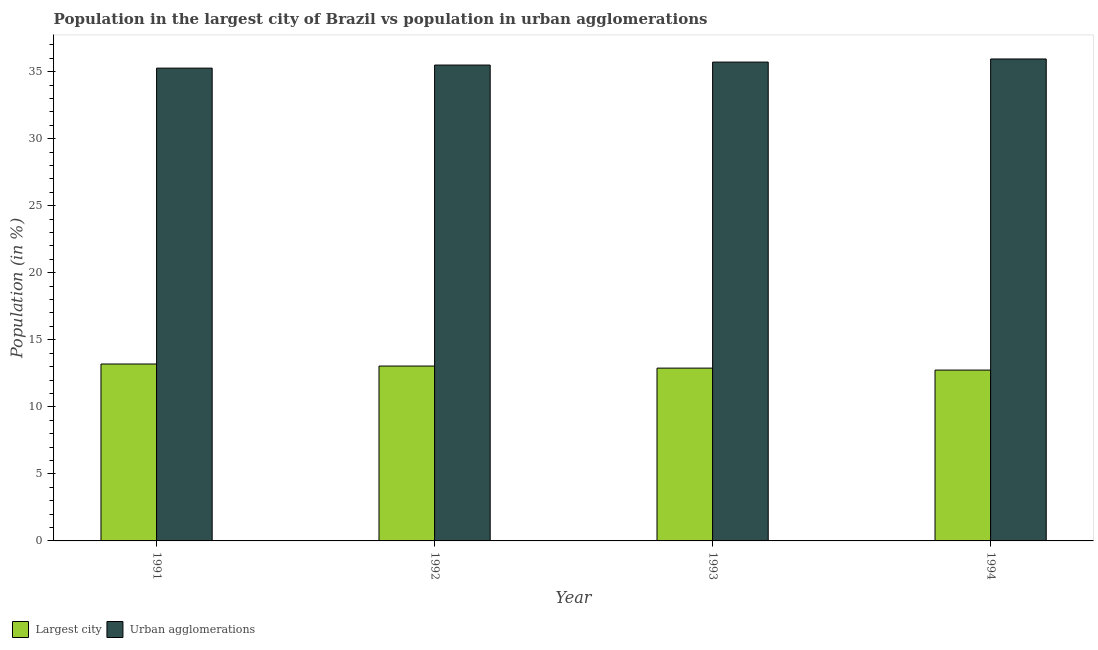How many groups of bars are there?
Your answer should be compact. 4. What is the population in urban agglomerations in 1991?
Keep it short and to the point. 35.26. Across all years, what is the maximum population in urban agglomerations?
Your answer should be compact. 35.94. Across all years, what is the minimum population in the largest city?
Provide a short and direct response. 12.74. In which year was the population in the largest city minimum?
Your answer should be very brief. 1994. What is the total population in urban agglomerations in the graph?
Give a very brief answer. 142.4. What is the difference between the population in the largest city in 1991 and that in 1992?
Offer a very short reply. 0.15. What is the difference between the population in urban agglomerations in 1992 and the population in the largest city in 1994?
Provide a succinct answer. -0.45. What is the average population in urban agglomerations per year?
Keep it short and to the point. 35.6. In the year 1991, what is the difference between the population in urban agglomerations and population in the largest city?
Provide a short and direct response. 0. In how many years, is the population in the largest city greater than 8 %?
Your response must be concise. 4. What is the ratio of the population in urban agglomerations in 1991 to that in 1992?
Your response must be concise. 0.99. Is the difference between the population in the largest city in 1991 and 1994 greater than the difference between the population in urban agglomerations in 1991 and 1994?
Provide a succinct answer. No. What is the difference between the highest and the second highest population in urban agglomerations?
Offer a terse response. 0.23. What is the difference between the highest and the lowest population in the largest city?
Your response must be concise. 0.45. What does the 1st bar from the left in 1994 represents?
Make the answer very short. Largest city. What does the 1st bar from the right in 1991 represents?
Offer a terse response. Urban agglomerations. How many years are there in the graph?
Your answer should be compact. 4. What is the difference between two consecutive major ticks on the Y-axis?
Offer a very short reply. 5. Does the graph contain any zero values?
Give a very brief answer. No. Does the graph contain grids?
Your answer should be compact. No. How are the legend labels stacked?
Your answer should be compact. Horizontal. What is the title of the graph?
Your answer should be very brief. Population in the largest city of Brazil vs population in urban agglomerations. Does "Arms imports" appear as one of the legend labels in the graph?
Give a very brief answer. No. What is the label or title of the X-axis?
Keep it short and to the point. Year. What is the label or title of the Y-axis?
Ensure brevity in your answer.  Population (in %). What is the Population (in %) of Largest city in 1991?
Provide a succinct answer. 13.19. What is the Population (in %) in Urban agglomerations in 1991?
Your answer should be very brief. 35.26. What is the Population (in %) in Largest city in 1992?
Your answer should be compact. 13.04. What is the Population (in %) in Urban agglomerations in 1992?
Offer a terse response. 35.49. What is the Population (in %) of Largest city in 1993?
Your answer should be compact. 12.89. What is the Population (in %) of Urban agglomerations in 1993?
Provide a succinct answer. 35.71. What is the Population (in %) in Largest city in 1994?
Make the answer very short. 12.74. What is the Population (in %) of Urban agglomerations in 1994?
Provide a short and direct response. 35.94. Across all years, what is the maximum Population (in %) of Largest city?
Ensure brevity in your answer.  13.19. Across all years, what is the maximum Population (in %) in Urban agglomerations?
Offer a terse response. 35.94. Across all years, what is the minimum Population (in %) of Largest city?
Your answer should be very brief. 12.74. Across all years, what is the minimum Population (in %) in Urban agglomerations?
Make the answer very short. 35.26. What is the total Population (in %) of Largest city in the graph?
Offer a terse response. 51.86. What is the total Population (in %) in Urban agglomerations in the graph?
Offer a very short reply. 142.4. What is the difference between the Population (in %) in Largest city in 1991 and that in 1992?
Keep it short and to the point. 0.15. What is the difference between the Population (in %) of Urban agglomerations in 1991 and that in 1992?
Provide a short and direct response. -0.23. What is the difference between the Population (in %) of Largest city in 1991 and that in 1993?
Your response must be concise. 0.31. What is the difference between the Population (in %) of Urban agglomerations in 1991 and that in 1993?
Keep it short and to the point. -0.45. What is the difference between the Population (in %) of Largest city in 1991 and that in 1994?
Keep it short and to the point. 0.45. What is the difference between the Population (in %) of Urban agglomerations in 1991 and that in 1994?
Provide a succinct answer. -0.68. What is the difference between the Population (in %) of Largest city in 1992 and that in 1993?
Give a very brief answer. 0.15. What is the difference between the Population (in %) in Urban agglomerations in 1992 and that in 1993?
Give a very brief answer. -0.22. What is the difference between the Population (in %) of Largest city in 1992 and that in 1994?
Your answer should be compact. 0.3. What is the difference between the Population (in %) in Urban agglomerations in 1992 and that in 1994?
Your response must be concise. -0.45. What is the difference between the Population (in %) of Largest city in 1993 and that in 1994?
Ensure brevity in your answer.  0.15. What is the difference between the Population (in %) of Urban agglomerations in 1993 and that in 1994?
Keep it short and to the point. -0.23. What is the difference between the Population (in %) in Largest city in 1991 and the Population (in %) in Urban agglomerations in 1992?
Your response must be concise. -22.3. What is the difference between the Population (in %) of Largest city in 1991 and the Population (in %) of Urban agglomerations in 1993?
Ensure brevity in your answer.  -22.52. What is the difference between the Population (in %) of Largest city in 1991 and the Population (in %) of Urban agglomerations in 1994?
Make the answer very short. -22.75. What is the difference between the Population (in %) of Largest city in 1992 and the Population (in %) of Urban agglomerations in 1993?
Offer a terse response. -22.67. What is the difference between the Population (in %) of Largest city in 1992 and the Population (in %) of Urban agglomerations in 1994?
Keep it short and to the point. -22.9. What is the difference between the Population (in %) in Largest city in 1993 and the Population (in %) in Urban agglomerations in 1994?
Your answer should be compact. -23.06. What is the average Population (in %) in Largest city per year?
Ensure brevity in your answer.  12.97. What is the average Population (in %) of Urban agglomerations per year?
Your answer should be compact. 35.6. In the year 1991, what is the difference between the Population (in %) of Largest city and Population (in %) of Urban agglomerations?
Your answer should be compact. -22.07. In the year 1992, what is the difference between the Population (in %) in Largest city and Population (in %) in Urban agglomerations?
Make the answer very short. -22.45. In the year 1993, what is the difference between the Population (in %) of Largest city and Population (in %) of Urban agglomerations?
Make the answer very short. -22.82. In the year 1994, what is the difference between the Population (in %) of Largest city and Population (in %) of Urban agglomerations?
Provide a short and direct response. -23.2. What is the ratio of the Population (in %) in Largest city in 1991 to that in 1992?
Offer a terse response. 1.01. What is the ratio of the Population (in %) of Largest city in 1991 to that in 1993?
Ensure brevity in your answer.  1.02. What is the ratio of the Population (in %) in Urban agglomerations in 1991 to that in 1993?
Give a very brief answer. 0.99. What is the ratio of the Population (in %) of Largest city in 1991 to that in 1994?
Give a very brief answer. 1.04. What is the ratio of the Population (in %) of Urban agglomerations in 1992 to that in 1993?
Provide a succinct answer. 0.99. What is the ratio of the Population (in %) of Largest city in 1992 to that in 1994?
Ensure brevity in your answer.  1.02. What is the ratio of the Population (in %) in Urban agglomerations in 1992 to that in 1994?
Your response must be concise. 0.99. What is the ratio of the Population (in %) of Largest city in 1993 to that in 1994?
Offer a very short reply. 1.01. What is the difference between the highest and the second highest Population (in %) of Largest city?
Give a very brief answer. 0.15. What is the difference between the highest and the second highest Population (in %) of Urban agglomerations?
Your answer should be very brief. 0.23. What is the difference between the highest and the lowest Population (in %) of Largest city?
Your answer should be very brief. 0.45. What is the difference between the highest and the lowest Population (in %) of Urban agglomerations?
Offer a very short reply. 0.68. 